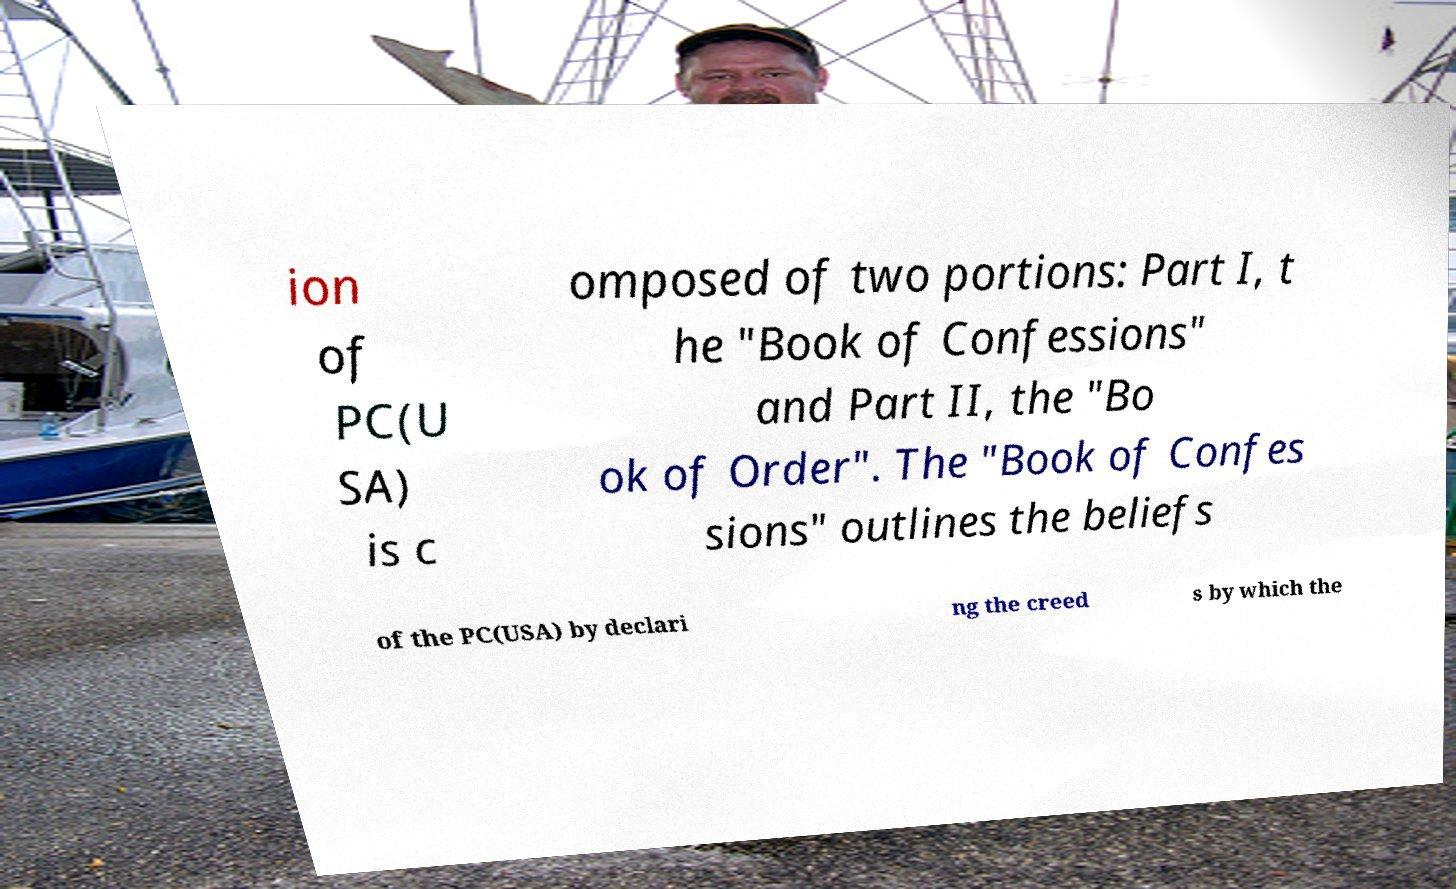I need the written content from this picture converted into text. Can you do that? ion of PC(U SA) is c omposed of two portions: Part I, t he "Book of Confessions" and Part II, the "Bo ok of Order". The "Book of Confes sions" outlines the beliefs of the PC(USA) by declari ng the creed s by which the 